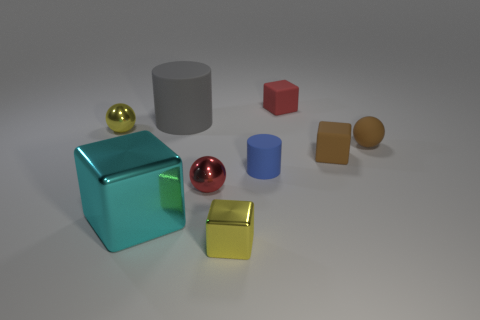Add 1 small yellow cubes. How many objects exist? 10 Subtract all cubes. How many objects are left? 5 Add 8 tiny matte balls. How many tiny matte balls are left? 9 Add 8 tiny blue matte cylinders. How many tiny blue matte cylinders exist? 9 Subtract 1 brown spheres. How many objects are left? 8 Subtract all blue rubber things. Subtract all metal balls. How many objects are left? 6 